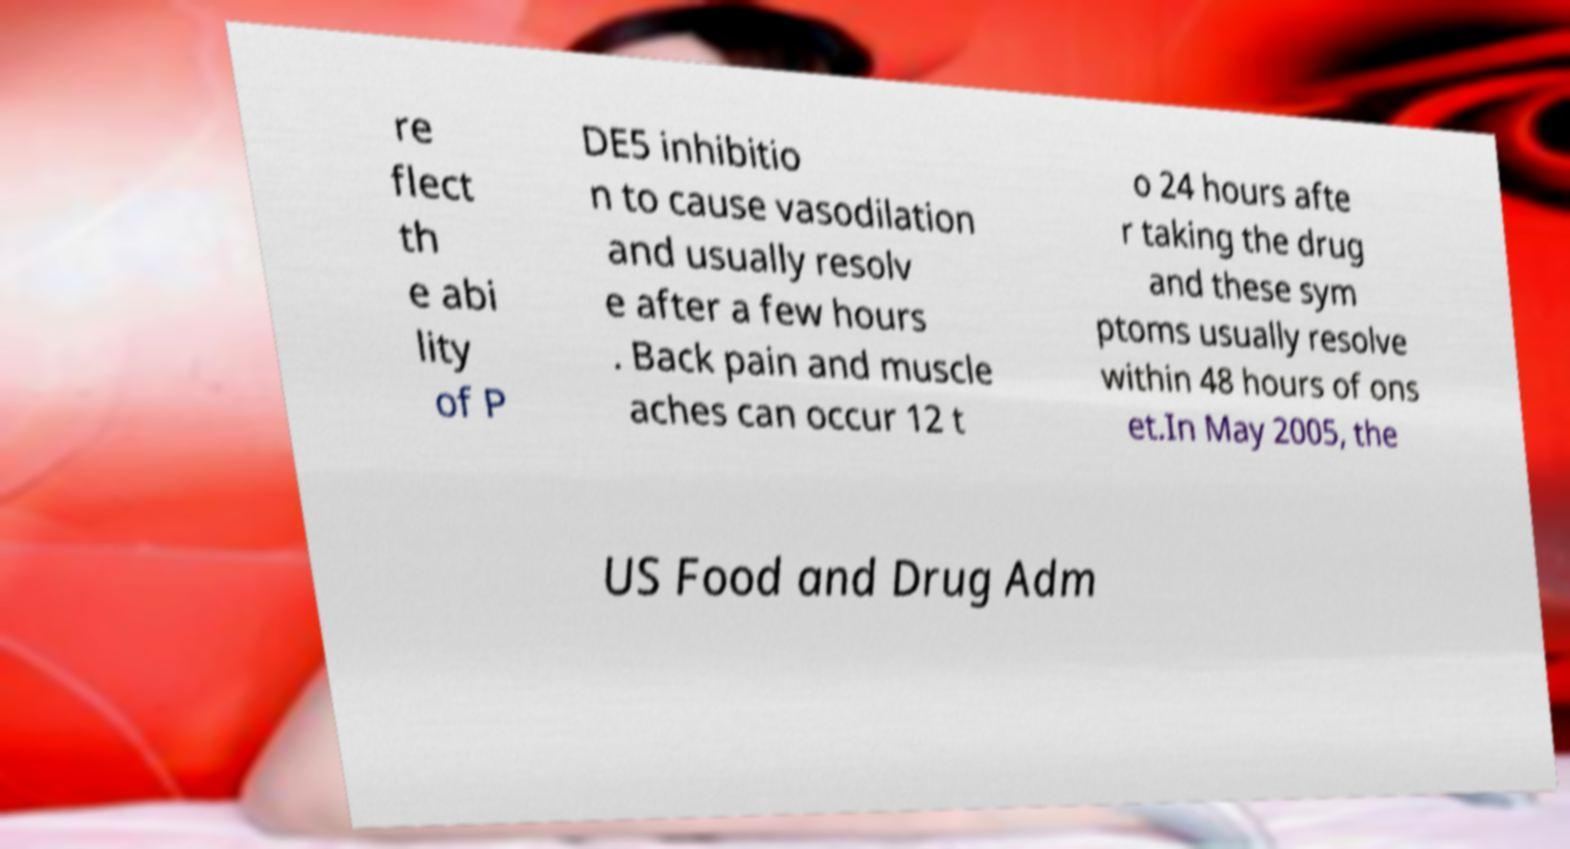There's text embedded in this image that I need extracted. Can you transcribe it verbatim? re flect th e abi lity of P DE5 inhibitio n to cause vasodilation and usually resolv e after a few hours . Back pain and muscle aches can occur 12 t o 24 hours afte r taking the drug and these sym ptoms usually resolve within 48 hours of ons et.In May 2005, the US Food and Drug Adm 